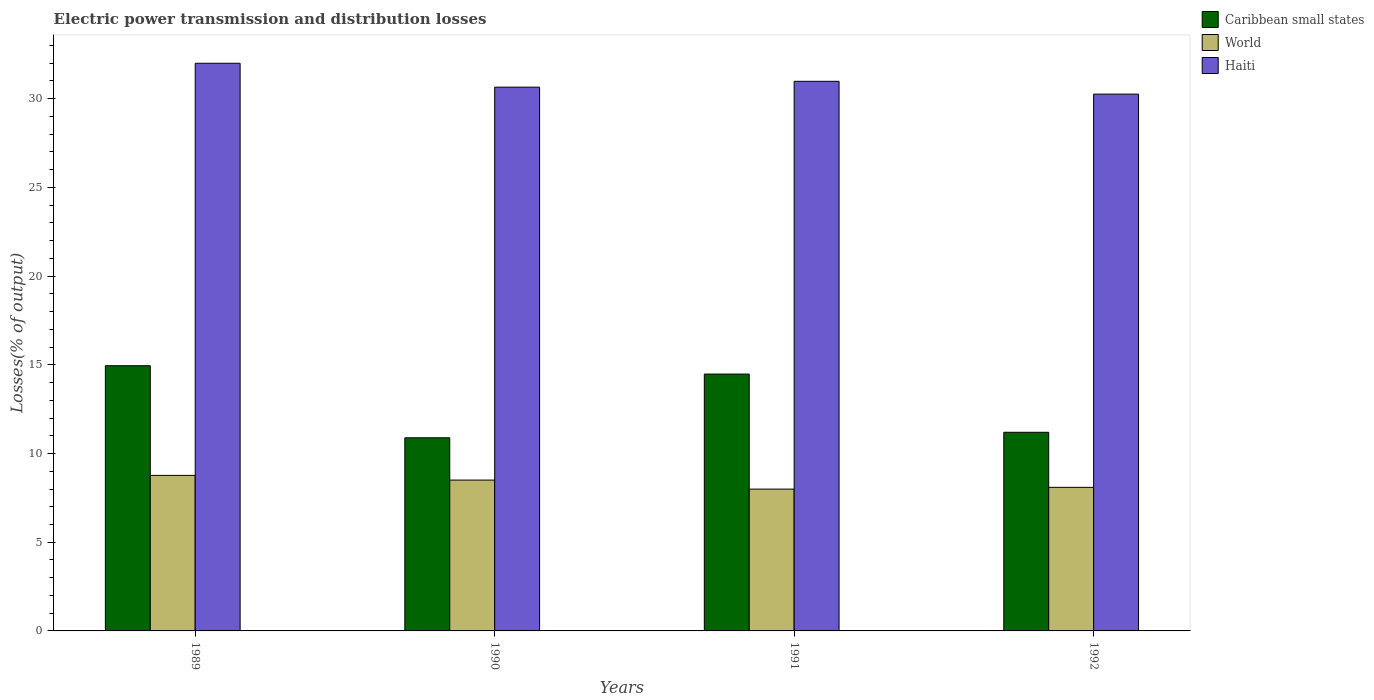How many bars are there on the 3rd tick from the left?
Give a very brief answer. 3. How many bars are there on the 1st tick from the right?
Give a very brief answer. 3. Across all years, what is the minimum electric power transmission and distribution losses in Haiti?
Offer a terse response. 30.26. In which year was the electric power transmission and distribution losses in World maximum?
Give a very brief answer. 1989. What is the total electric power transmission and distribution losses in World in the graph?
Keep it short and to the point. 33.36. What is the difference between the electric power transmission and distribution losses in World in 1990 and that in 1992?
Make the answer very short. 0.41. What is the difference between the electric power transmission and distribution losses in World in 1989 and the electric power transmission and distribution losses in Caribbean small states in 1990?
Provide a succinct answer. -2.12. What is the average electric power transmission and distribution losses in Caribbean small states per year?
Your answer should be very brief. 12.88. In the year 1991, what is the difference between the electric power transmission and distribution losses in Haiti and electric power transmission and distribution losses in Caribbean small states?
Make the answer very short. 16.5. In how many years, is the electric power transmission and distribution losses in Haiti greater than 13 %?
Offer a terse response. 4. What is the ratio of the electric power transmission and distribution losses in World in 1989 to that in 1992?
Ensure brevity in your answer.  1.08. What is the difference between the highest and the second highest electric power transmission and distribution losses in Caribbean small states?
Ensure brevity in your answer.  0.47. What is the difference between the highest and the lowest electric power transmission and distribution losses in Haiti?
Give a very brief answer. 1.74. What does the 1st bar from the left in 1989 represents?
Your response must be concise. Caribbean small states. What does the 3rd bar from the right in 1991 represents?
Your answer should be compact. Caribbean small states. Are all the bars in the graph horizontal?
Make the answer very short. No. What is the difference between two consecutive major ticks on the Y-axis?
Offer a terse response. 5. Does the graph contain grids?
Provide a short and direct response. No. How many legend labels are there?
Keep it short and to the point. 3. How are the legend labels stacked?
Make the answer very short. Vertical. What is the title of the graph?
Provide a short and direct response. Electric power transmission and distribution losses. Does "Fiji" appear as one of the legend labels in the graph?
Your response must be concise. No. What is the label or title of the X-axis?
Provide a succinct answer. Years. What is the label or title of the Y-axis?
Make the answer very short. Losses(% of output). What is the Losses(% of output) in Caribbean small states in 1989?
Offer a terse response. 14.95. What is the Losses(% of output) in World in 1989?
Your answer should be compact. 8.77. What is the Losses(% of output) in Caribbean small states in 1990?
Make the answer very short. 10.89. What is the Losses(% of output) in World in 1990?
Provide a succinct answer. 8.5. What is the Losses(% of output) of Haiti in 1990?
Make the answer very short. 30.65. What is the Losses(% of output) of Caribbean small states in 1991?
Your answer should be very brief. 14.48. What is the Losses(% of output) of World in 1991?
Offer a terse response. 7.99. What is the Losses(% of output) in Haiti in 1991?
Your answer should be very brief. 30.98. What is the Losses(% of output) of Caribbean small states in 1992?
Make the answer very short. 11.2. What is the Losses(% of output) in World in 1992?
Give a very brief answer. 8.09. What is the Losses(% of output) of Haiti in 1992?
Ensure brevity in your answer.  30.26. Across all years, what is the maximum Losses(% of output) of Caribbean small states?
Offer a very short reply. 14.95. Across all years, what is the maximum Losses(% of output) in World?
Keep it short and to the point. 8.77. Across all years, what is the maximum Losses(% of output) of Haiti?
Offer a very short reply. 32. Across all years, what is the minimum Losses(% of output) of Caribbean small states?
Give a very brief answer. 10.89. Across all years, what is the minimum Losses(% of output) of World?
Your answer should be compact. 7.99. Across all years, what is the minimum Losses(% of output) of Haiti?
Your response must be concise. 30.26. What is the total Losses(% of output) of Caribbean small states in the graph?
Provide a short and direct response. 51.51. What is the total Losses(% of output) in World in the graph?
Give a very brief answer. 33.36. What is the total Losses(% of output) of Haiti in the graph?
Provide a succinct answer. 123.9. What is the difference between the Losses(% of output) in Caribbean small states in 1989 and that in 1990?
Give a very brief answer. 4.06. What is the difference between the Losses(% of output) in World in 1989 and that in 1990?
Your answer should be compact. 0.26. What is the difference between the Losses(% of output) of Haiti in 1989 and that in 1990?
Provide a short and direct response. 1.35. What is the difference between the Losses(% of output) of Caribbean small states in 1989 and that in 1991?
Your answer should be compact. 0.47. What is the difference between the Losses(% of output) of World in 1989 and that in 1991?
Ensure brevity in your answer.  0.77. What is the difference between the Losses(% of output) in Haiti in 1989 and that in 1991?
Your answer should be very brief. 1.02. What is the difference between the Losses(% of output) of Caribbean small states in 1989 and that in 1992?
Your answer should be compact. 3.75. What is the difference between the Losses(% of output) of World in 1989 and that in 1992?
Your response must be concise. 0.67. What is the difference between the Losses(% of output) in Haiti in 1989 and that in 1992?
Keep it short and to the point. 1.74. What is the difference between the Losses(% of output) of Caribbean small states in 1990 and that in 1991?
Offer a very short reply. -3.59. What is the difference between the Losses(% of output) of World in 1990 and that in 1991?
Give a very brief answer. 0.51. What is the difference between the Losses(% of output) of Haiti in 1990 and that in 1991?
Keep it short and to the point. -0.33. What is the difference between the Losses(% of output) in Caribbean small states in 1990 and that in 1992?
Offer a very short reply. -0.31. What is the difference between the Losses(% of output) in World in 1990 and that in 1992?
Offer a very short reply. 0.41. What is the difference between the Losses(% of output) of Haiti in 1990 and that in 1992?
Offer a very short reply. 0.39. What is the difference between the Losses(% of output) in Caribbean small states in 1991 and that in 1992?
Give a very brief answer. 3.28. What is the difference between the Losses(% of output) of World in 1991 and that in 1992?
Your answer should be very brief. -0.1. What is the difference between the Losses(% of output) in Haiti in 1991 and that in 1992?
Provide a succinct answer. 0.72. What is the difference between the Losses(% of output) in Caribbean small states in 1989 and the Losses(% of output) in World in 1990?
Offer a terse response. 6.45. What is the difference between the Losses(% of output) of Caribbean small states in 1989 and the Losses(% of output) of Haiti in 1990?
Provide a short and direct response. -15.7. What is the difference between the Losses(% of output) in World in 1989 and the Losses(% of output) in Haiti in 1990?
Offer a terse response. -21.89. What is the difference between the Losses(% of output) in Caribbean small states in 1989 and the Losses(% of output) in World in 1991?
Your answer should be very brief. 6.96. What is the difference between the Losses(% of output) of Caribbean small states in 1989 and the Losses(% of output) of Haiti in 1991?
Provide a succinct answer. -16.03. What is the difference between the Losses(% of output) in World in 1989 and the Losses(% of output) in Haiti in 1991?
Make the answer very short. -22.22. What is the difference between the Losses(% of output) in Caribbean small states in 1989 and the Losses(% of output) in World in 1992?
Your answer should be compact. 6.86. What is the difference between the Losses(% of output) in Caribbean small states in 1989 and the Losses(% of output) in Haiti in 1992?
Your response must be concise. -15.31. What is the difference between the Losses(% of output) in World in 1989 and the Losses(% of output) in Haiti in 1992?
Ensure brevity in your answer.  -21.49. What is the difference between the Losses(% of output) of Caribbean small states in 1990 and the Losses(% of output) of World in 1991?
Your response must be concise. 2.89. What is the difference between the Losses(% of output) in Caribbean small states in 1990 and the Losses(% of output) in Haiti in 1991?
Provide a short and direct response. -20.1. What is the difference between the Losses(% of output) of World in 1990 and the Losses(% of output) of Haiti in 1991?
Your response must be concise. -22.48. What is the difference between the Losses(% of output) of Caribbean small states in 1990 and the Losses(% of output) of World in 1992?
Provide a short and direct response. 2.79. What is the difference between the Losses(% of output) of Caribbean small states in 1990 and the Losses(% of output) of Haiti in 1992?
Provide a short and direct response. -19.37. What is the difference between the Losses(% of output) in World in 1990 and the Losses(% of output) in Haiti in 1992?
Your answer should be compact. -21.76. What is the difference between the Losses(% of output) in Caribbean small states in 1991 and the Losses(% of output) in World in 1992?
Provide a short and direct response. 6.39. What is the difference between the Losses(% of output) of Caribbean small states in 1991 and the Losses(% of output) of Haiti in 1992?
Give a very brief answer. -15.78. What is the difference between the Losses(% of output) in World in 1991 and the Losses(% of output) in Haiti in 1992?
Provide a short and direct response. -22.27. What is the average Losses(% of output) of Caribbean small states per year?
Offer a terse response. 12.88. What is the average Losses(% of output) of World per year?
Offer a very short reply. 8.34. What is the average Losses(% of output) in Haiti per year?
Your answer should be very brief. 30.97. In the year 1989, what is the difference between the Losses(% of output) in Caribbean small states and Losses(% of output) in World?
Provide a succinct answer. 6.18. In the year 1989, what is the difference between the Losses(% of output) in Caribbean small states and Losses(% of output) in Haiti?
Your answer should be compact. -17.05. In the year 1989, what is the difference between the Losses(% of output) in World and Losses(% of output) in Haiti?
Your answer should be compact. -23.23. In the year 1990, what is the difference between the Losses(% of output) in Caribbean small states and Losses(% of output) in World?
Ensure brevity in your answer.  2.38. In the year 1990, what is the difference between the Losses(% of output) in Caribbean small states and Losses(% of output) in Haiti?
Your answer should be compact. -19.77. In the year 1990, what is the difference between the Losses(% of output) in World and Losses(% of output) in Haiti?
Your answer should be very brief. -22.15. In the year 1991, what is the difference between the Losses(% of output) in Caribbean small states and Losses(% of output) in World?
Offer a very short reply. 6.49. In the year 1991, what is the difference between the Losses(% of output) of Caribbean small states and Losses(% of output) of Haiti?
Give a very brief answer. -16.5. In the year 1991, what is the difference between the Losses(% of output) of World and Losses(% of output) of Haiti?
Provide a succinct answer. -22.99. In the year 1992, what is the difference between the Losses(% of output) in Caribbean small states and Losses(% of output) in World?
Your answer should be very brief. 3.1. In the year 1992, what is the difference between the Losses(% of output) of Caribbean small states and Losses(% of output) of Haiti?
Your answer should be very brief. -19.06. In the year 1992, what is the difference between the Losses(% of output) of World and Losses(% of output) of Haiti?
Ensure brevity in your answer.  -22.17. What is the ratio of the Losses(% of output) of Caribbean small states in 1989 to that in 1990?
Your answer should be very brief. 1.37. What is the ratio of the Losses(% of output) of World in 1989 to that in 1990?
Make the answer very short. 1.03. What is the ratio of the Losses(% of output) in Haiti in 1989 to that in 1990?
Your response must be concise. 1.04. What is the ratio of the Losses(% of output) of Caribbean small states in 1989 to that in 1991?
Your response must be concise. 1.03. What is the ratio of the Losses(% of output) of World in 1989 to that in 1991?
Your response must be concise. 1.1. What is the ratio of the Losses(% of output) in Haiti in 1989 to that in 1991?
Keep it short and to the point. 1.03. What is the ratio of the Losses(% of output) of Caribbean small states in 1989 to that in 1992?
Offer a very short reply. 1.34. What is the ratio of the Losses(% of output) of World in 1989 to that in 1992?
Provide a succinct answer. 1.08. What is the ratio of the Losses(% of output) in Haiti in 1989 to that in 1992?
Offer a terse response. 1.06. What is the ratio of the Losses(% of output) in Caribbean small states in 1990 to that in 1991?
Offer a very short reply. 0.75. What is the ratio of the Losses(% of output) of World in 1990 to that in 1991?
Your response must be concise. 1.06. What is the ratio of the Losses(% of output) of Caribbean small states in 1990 to that in 1992?
Provide a succinct answer. 0.97. What is the ratio of the Losses(% of output) of World in 1990 to that in 1992?
Your response must be concise. 1.05. What is the ratio of the Losses(% of output) in Haiti in 1990 to that in 1992?
Provide a short and direct response. 1.01. What is the ratio of the Losses(% of output) in Caribbean small states in 1991 to that in 1992?
Make the answer very short. 1.29. What is the ratio of the Losses(% of output) in Haiti in 1991 to that in 1992?
Offer a terse response. 1.02. What is the difference between the highest and the second highest Losses(% of output) of Caribbean small states?
Your response must be concise. 0.47. What is the difference between the highest and the second highest Losses(% of output) in World?
Your answer should be compact. 0.26. What is the difference between the highest and the second highest Losses(% of output) of Haiti?
Your response must be concise. 1.02. What is the difference between the highest and the lowest Losses(% of output) in Caribbean small states?
Provide a short and direct response. 4.06. What is the difference between the highest and the lowest Losses(% of output) of World?
Ensure brevity in your answer.  0.77. What is the difference between the highest and the lowest Losses(% of output) in Haiti?
Give a very brief answer. 1.74. 